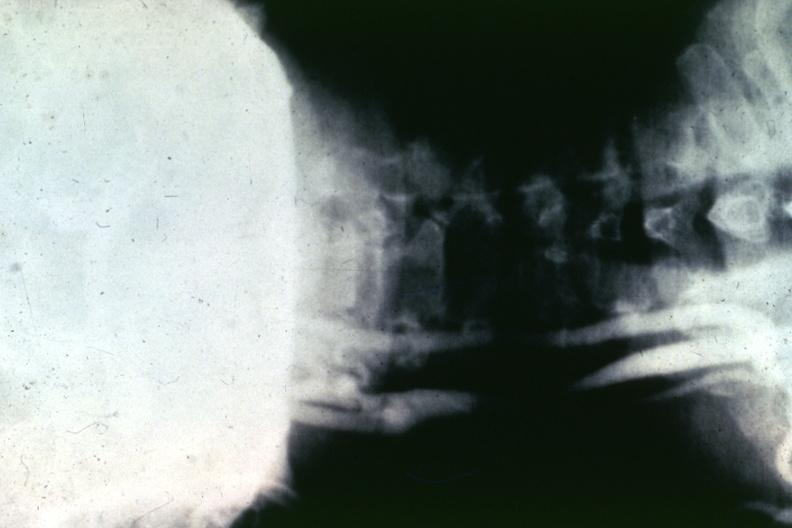s this image shows of smooth muscle cell with lipid in sarcoplasm and lipid present?
Answer the question using a single word or phrase. No 